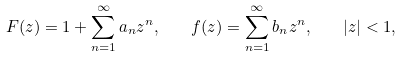Convert formula to latex. <formula><loc_0><loc_0><loc_500><loc_500>F ( z ) = 1 + \sum _ { n = 1 } ^ { \infty } a _ { n } z ^ { n } , \quad f ( z ) = \sum _ { n = 1 } ^ { \infty } b _ { n } z ^ { n } , \quad | z | < 1 ,</formula> 